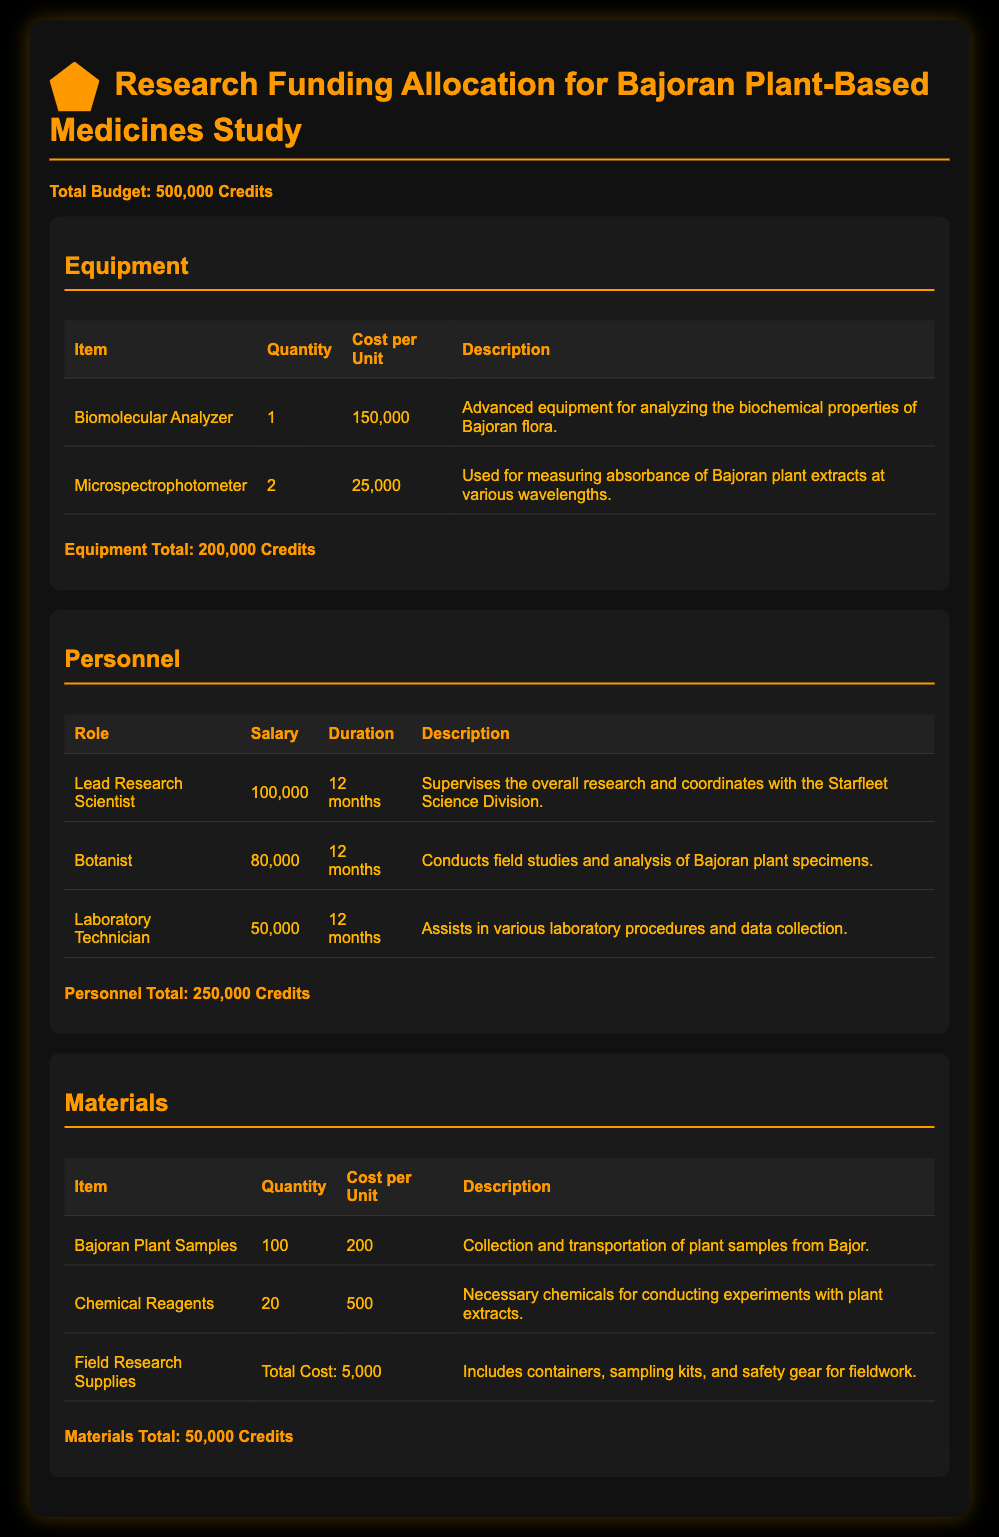What is the total budget? The total budget is clearly stated in the document as the overall funding allocation for the study.
Answer: 500,000 Credits How many Biomolecular Analyzers are planned for purchase? The document lists the quantity of each equipment item, specifying how many of each are needed.
Answer: 1 What is the salary for the Lead Research Scientist? The document details the salary associated with each personnel role involved in the study.
Answer: 100,000 What are the total costs for personnel? The total costs for personnel is calculated by summing up the salaries listed for each relevant role in the personnel section.
Answer: 250,000 Credits How much does each Bajoran Plant Sample cost? The cost per unit for Bajoran Plant Samples is clearly indicated next to the item in the materials section.
Answer: 200 What is included in the Field Research Supplies? The document describes the contents of this category, highlighting the variety of supplies it encompasses.
Answer: Containers, sampling kits, and safety gear What is the total cost for equipment? The document sums the cost of each equipment item to present a total for this category.
Answer: 200,000 Credits How many chemical reagents are required? The number of chemical reagents needed is specified in the materials section of the budget.
Answer: 20 